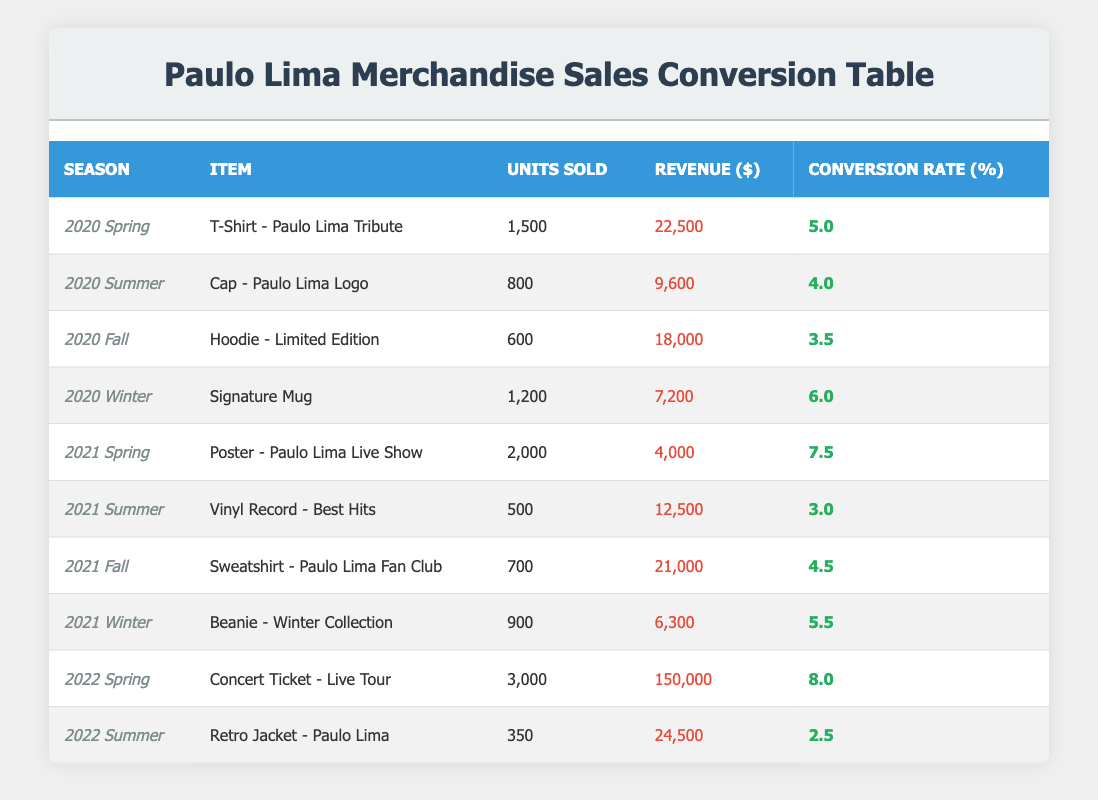What was the total revenue generated from merchandise sales in the Spring seasons across all years? To find the total revenue from Spring seasons, look at 2020 Spring and 2021 Spring. The revenue for 2020 Spring is 22,500 and for 2021 Spring is 4,000. Adding them together gives: 22,500 + 4,000 = 26,500.
Answer: 26,500 Which item had the highest conversion rate, and what was that rate? To determine the highest conversion rate, we need to compare all the conversion rates in the table. The conversion rates are: 5.0, 4.0, 3.5, 6.0, 7.5, 3.0, 4.5, 5.5, 8.0, 2.5. The maximum among them is 8.0, which corresponds to the 'Concert Ticket - Live Tour' in 2022 Spring.
Answer: Concert Ticket - Live Tour; 8.0 How many units of the 'Hoodie - Limited Edition' were sold? The 'Hoodie - Limited Edition' corresponds to the 2020 Fall season. According to the table, it displayed 600 units sold.
Answer: 600 Was the revenue for 'Beanie - Winter Collection' greater than the revenue for 'Cap - Paulo Lima Logo'? The revenue for 'Beanie - Winter Collection' in 2021 Winter is 6,300 and for 'Cap - Paulo Lima Logo' in 2020 Summer is 9,600. Since 6,300 is less than 9,600, the statement is false.
Answer: No What is the average number of units sold for all items in the 2021 season? First, we find the number of units sold for each season in 2021: 2,000 (Spring) + 500 (Summer) + 700 (Fall) + 900 (Winter) = 4,100 units. Dividing this by the four items gives an average of 4,100 / 4 = 1,025.
Answer: 1,025 Which season had the lowest revenue, and what was that revenue? Look for the lowest revenue in the table. The revenue values are: 22,500; 9,600; 18,000; 7,200; 4,000; 12,500; 21,000; 6,300; 150,000; 24,500. The lowest is 4,000, from the 2021 Spring season.
Answer: 2021 Spring; 4,000 How many more units were sold of the 'Concert Ticket - Live Tour' compared to the 'Retro Jacket - Paulo Lima'? The 'Concert Ticket - Live Tour' sold 3,000 units and the 'Retro Jacket - Paulo Lima' sold 350 units. The difference is 3,000 - 350 = 2,650 units.
Answer: 2,650 Did the 'T-Shirt - Paulo Lima Tribute' sell more units than the combined sales of the 'Vinyl Record - Best Hits' and 'Sweatshirt - Paulo Lima Fan Club'? The 'T-Shirt - Paulo Lima Tribute' sold 1,500 units. The units sold for 'Vinyl Record - Best Hits' are 500 and for 'Sweatshirt - Paulo Lima Fan Club' are 700. Combined, they sold 500 + 700 = 1,200 units. Since 1,500 is more than 1,200, the answer is yes.
Answer: Yes What was the total conversion rate for all sales in 2020? Add together the conversion rates for all seasons in 2020: 5.0 (Spring) + 4.0 (Summer) + 3.5 (Fall) + 6.0 (Winter) = 18.5.
Answer: 18.5 